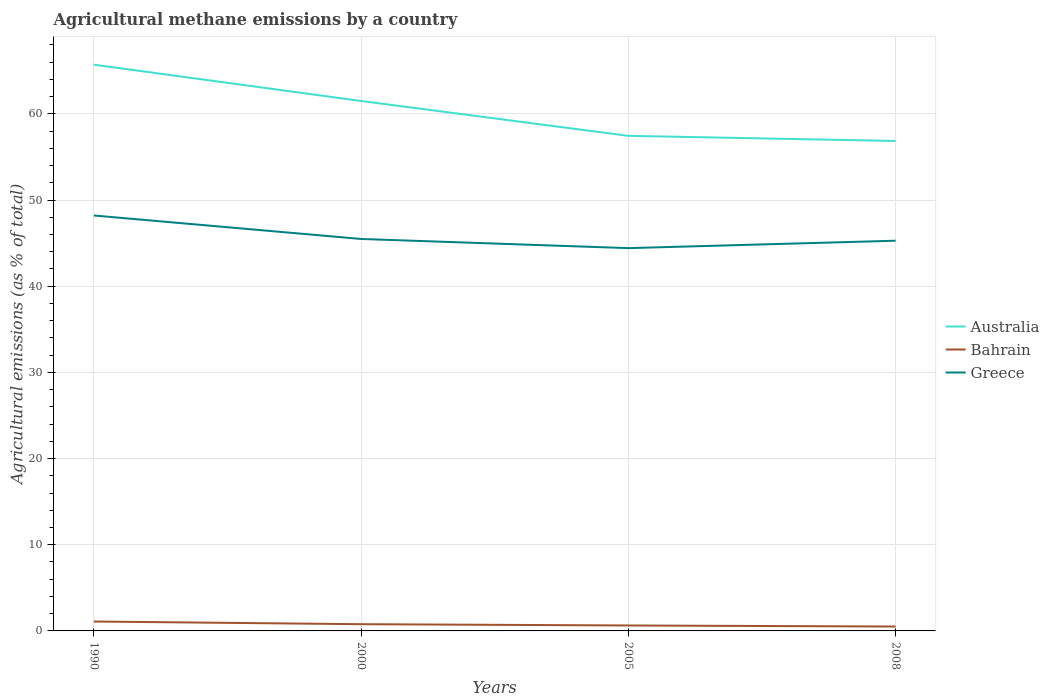How many different coloured lines are there?
Ensure brevity in your answer.  3. Does the line corresponding to Greece intersect with the line corresponding to Australia?
Your answer should be very brief. No. Across all years, what is the maximum amount of agricultural methane emitted in Bahrain?
Your response must be concise. 0.51. In which year was the amount of agricultural methane emitted in Australia maximum?
Ensure brevity in your answer.  2008. What is the total amount of agricultural methane emitted in Australia in the graph?
Give a very brief answer. 8.26. What is the difference between the highest and the second highest amount of agricultural methane emitted in Australia?
Provide a succinct answer. 8.85. What is the difference between the highest and the lowest amount of agricultural methane emitted in Australia?
Your answer should be compact. 2. Is the amount of agricultural methane emitted in Australia strictly greater than the amount of agricultural methane emitted in Greece over the years?
Provide a short and direct response. No. How many lines are there?
Offer a very short reply. 3. Does the graph contain any zero values?
Provide a short and direct response. No. How are the legend labels stacked?
Give a very brief answer. Vertical. What is the title of the graph?
Keep it short and to the point. Agricultural methane emissions by a country. Does "Least developed countries" appear as one of the legend labels in the graph?
Make the answer very short. No. What is the label or title of the Y-axis?
Your answer should be compact. Agricultural emissions (as % of total). What is the Agricultural emissions (as % of total) of Australia in 1990?
Give a very brief answer. 65.71. What is the Agricultural emissions (as % of total) in Bahrain in 1990?
Make the answer very short. 1.09. What is the Agricultural emissions (as % of total) in Greece in 1990?
Ensure brevity in your answer.  48.21. What is the Agricultural emissions (as % of total) in Australia in 2000?
Your answer should be compact. 61.5. What is the Agricultural emissions (as % of total) in Bahrain in 2000?
Your answer should be very brief. 0.78. What is the Agricultural emissions (as % of total) of Greece in 2000?
Offer a very short reply. 45.48. What is the Agricultural emissions (as % of total) in Australia in 2005?
Offer a terse response. 57.45. What is the Agricultural emissions (as % of total) of Bahrain in 2005?
Offer a terse response. 0.63. What is the Agricultural emissions (as % of total) of Greece in 2005?
Provide a succinct answer. 44.42. What is the Agricultural emissions (as % of total) of Australia in 2008?
Your answer should be compact. 56.85. What is the Agricultural emissions (as % of total) of Bahrain in 2008?
Provide a succinct answer. 0.51. What is the Agricultural emissions (as % of total) in Greece in 2008?
Offer a very short reply. 45.28. Across all years, what is the maximum Agricultural emissions (as % of total) of Australia?
Make the answer very short. 65.71. Across all years, what is the maximum Agricultural emissions (as % of total) in Bahrain?
Give a very brief answer. 1.09. Across all years, what is the maximum Agricultural emissions (as % of total) of Greece?
Your answer should be compact. 48.21. Across all years, what is the minimum Agricultural emissions (as % of total) of Australia?
Your answer should be very brief. 56.85. Across all years, what is the minimum Agricultural emissions (as % of total) of Bahrain?
Your answer should be very brief. 0.51. Across all years, what is the minimum Agricultural emissions (as % of total) in Greece?
Offer a terse response. 44.42. What is the total Agricultural emissions (as % of total) in Australia in the graph?
Ensure brevity in your answer.  241.51. What is the total Agricultural emissions (as % of total) of Bahrain in the graph?
Offer a very short reply. 3.02. What is the total Agricultural emissions (as % of total) of Greece in the graph?
Ensure brevity in your answer.  183.39. What is the difference between the Agricultural emissions (as % of total) in Australia in 1990 and that in 2000?
Offer a very short reply. 4.21. What is the difference between the Agricultural emissions (as % of total) in Bahrain in 1990 and that in 2000?
Offer a terse response. 0.31. What is the difference between the Agricultural emissions (as % of total) in Greece in 1990 and that in 2000?
Provide a succinct answer. 2.72. What is the difference between the Agricultural emissions (as % of total) of Australia in 1990 and that in 2005?
Ensure brevity in your answer.  8.26. What is the difference between the Agricultural emissions (as % of total) in Bahrain in 1990 and that in 2005?
Provide a succinct answer. 0.46. What is the difference between the Agricultural emissions (as % of total) in Greece in 1990 and that in 2005?
Offer a terse response. 3.79. What is the difference between the Agricultural emissions (as % of total) of Australia in 1990 and that in 2008?
Your answer should be very brief. 8.85. What is the difference between the Agricultural emissions (as % of total) in Bahrain in 1990 and that in 2008?
Make the answer very short. 0.58. What is the difference between the Agricultural emissions (as % of total) in Greece in 1990 and that in 2008?
Your response must be concise. 2.93. What is the difference between the Agricultural emissions (as % of total) of Australia in 2000 and that in 2005?
Ensure brevity in your answer.  4.04. What is the difference between the Agricultural emissions (as % of total) of Bahrain in 2000 and that in 2005?
Ensure brevity in your answer.  0.15. What is the difference between the Agricultural emissions (as % of total) in Greece in 2000 and that in 2005?
Offer a terse response. 1.06. What is the difference between the Agricultural emissions (as % of total) of Australia in 2000 and that in 2008?
Your response must be concise. 4.64. What is the difference between the Agricultural emissions (as % of total) of Bahrain in 2000 and that in 2008?
Your answer should be compact. 0.27. What is the difference between the Agricultural emissions (as % of total) of Greece in 2000 and that in 2008?
Provide a succinct answer. 0.2. What is the difference between the Agricultural emissions (as % of total) in Australia in 2005 and that in 2008?
Provide a succinct answer. 0.6. What is the difference between the Agricultural emissions (as % of total) of Bahrain in 2005 and that in 2008?
Your answer should be very brief. 0.12. What is the difference between the Agricultural emissions (as % of total) in Greece in 2005 and that in 2008?
Your response must be concise. -0.86. What is the difference between the Agricultural emissions (as % of total) of Australia in 1990 and the Agricultural emissions (as % of total) of Bahrain in 2000?
Offer a very short reply. 64.93. What is the difference between the Agricultural emissions (as % of total) in Australia in 1990 and the Agricultural emissions (as % of total) in Greece in 2000?
Provide a short and direct response. 20.23. What is the difference between the Agricultural emissions (as % of total) of Bahrain in 1990 and the Agricultural emissions (as % of total) of Greece in 2000?
Your answer should be compact. -44.39. What is the difference between the Agricultural emissions (as % of total) of Australia in 1990 and the Agricultural emissions (as % of total) of Bahrain in 2005?
Provide a short and direct response. 65.08. What is the difference between the Agricultural emissions (as % of total) of Australia in 1990 and the Agricultural emissions (as % of total) of Greece in 2005?
Offer a terse response. 21.29. What is the difference between the Agricultural emissions (as % of total) of Bahrain in 1990 and the Agricultural emissions (as % of total) of Greece in 2005?
Offer a very short reply. -43.33. What is the difference between the Agricultural emissions (as % of total) of Australia in 1990 and the Agricultural emissions (as % of total) of Bahrain in 2008?
Make the answer very short. 65.2. What is the difference between the Agricultural emissions (as % of total) in Australia in 1990 and the Agricultural emissions (as % of total) in Greece in 2008?
Make the answer very short. 20.43. What is the difference between the Agricultural emissions (as % of total) of Bahrain in 1990 and the Agricultural emissions (as % of total) of Greece in 2008?
Give a very brief answer. -44.19. What is the difference between the Agricultural emissions (as % of total) in Australia in 2000 and the Agricultural emissions (as % of total) in Bahrain in 2005?
Ensure brevity in your answer.  60.86. What is the difference between the Agricultural emissions (as % of total) in Australia in 2000 and the Agricultural emissions (as % of total) in Greece in 2005?
Provide a succinct answer. 17.08. What is the difference between the Agricultural emissions (as % of total) of Bahrain in 2000 and the Agricultural emissions (as % of total) of Greece in 2005?
Offer a terse response. -43.64. What is the difference between the Agricultural emissions (as % of total) in Australia in 2000 and the Agricultural emissions (as % of total) in Bahrain in 2008?
Make the answer very short. 60.99. What is the difference between the Agricultural emissions (as % of total) in Australia in 2000 and the Agricultural emissions (as % of total) in Greece in 2008?
Ensure brevity in your answer.  16.22. What is the difference between the Agricultural emissions (as % of total) in Bahrain in 2000 and the Agricultural emissions (as % of total) in Greece in 2008?
Ensure brevity in your answer.  -44.5. What is the difference between the Agricultural emissions (as % of total) in Australia in 2005 and the Agricultural emissions (as % of total) in Bahrain in 2008?
Offer a very short reply. 56.94. What is the difference between the Agricultural emissions (as % of total) in Australia in 2005 and the Agricultural emissions (as % of total) in Greece in 2008?
Offer a very short reply. 12.17. What is the difference between the Agricultural emissions (as % of total) in Bahrain in 2005 and the Agricultural emissions (as % of total) in Greece in 2008?
Offer a terse response. -44.65. What is the average Agricultural emissions (as % of total) of Australia per year?
Provide a short and direct response. 60.38. What is the average Agricultural emissions (as % of total) of Bahrain per year?
Offer a very short reply. 0.75. What is the average Agricultural emissions (as % of total) of Greece per year?
Your answer should be compact. 45.85. In the year 1990, what is the difference between the Agricultural emissions (as % of total) of Australia and Agricultural emissions (as % of total) of Bahrain?
Provide a short and direct response. 64.62. In the year 1990, what is the difference between the Agricultural emissions (as % of total) in Australia and Agricultural emissions (as % of total) in Greece?
Offer a very short reply. 17.5. In the year 1990, what is the difference between the Agricultural emissions (as % of total) in Bahrain and Agricultural emissions (as % of total) in Greece?
Offer a terse response. -47.12. In the year 2000, what is the difference between the Agricultural emissions (as % of total) of Australia and Agricultural emissions (as % of total) of Bahrain?
Offer a terse response. 60.72. In the year 2000, what is the difference between the Agricultural emissions (as % of total) in Australia and Agricultural emissions (as % of total) in Greece?
Offer a very short reply. 16.01. In the year 2000, what is the difference between the Agricultural emissions (as % of total) of Bahrain and Agricultural emissions (as % of total) of Greece?
Ensure brevity in your answer.  -44.7. In the year 2005, what is the difference between the Agricultural emissions (as % of total) of Australia and Agricultural emissions (as % of total) of Bahrain?
Offer a terse response. 56.82. In the year 2005, what is the difference between the Agricultural emissions (as % of total) in Australia and Agricultural emissions (as % of total) in Greece?
Your answer should be very brief. 13.03. In the year 2005, what is the difference between the Agricultural emissions (as % of total) in Bahrain and Agricultural emissions (as % of total) in Greece?
Provide a short and direct response. -43.79. In the year 2008, what is the difference between the Agricultural emissions (as % of total) of Australia and Agricultural emissions (as % of total) of Bahrain?
Your response must be concise. 56.34. In the year 2008, what is the difference between the Agricultural emissions (as % of total) of Australia and Agricultural emissions (as % of total) of Greece?
Offer a very short reply. 11.58. In the year 2008, what is the difference between the Agricultural emissions (as % of total) in Bahrain and Agricultural emissions (as % of total) in Greece?
Provide a succinct answer. -44.77. What is the ratio of the Agricultural emissions (as % of total) in Australia in 1990 to that in 2000?
Your response must be concise. 1.07. What is the ratio of the Agricultural emissions (as % of total) of Bahrain in 1990 to that in 2000?
Provide a short and direct response. 1.4. What is the ratio of the Agricultural emissions (as % of total) in Greece in 1990 to that in 2000?
Offer a terse response. 1.06. What is the ratio of the Agricultural emissions (as % of total) in Australia in 1990 to that in 2005?
Your response must be concise. 1.14. What is the ratio of the Agricultural emissions (as % of total) of Bahrain in 1990 to that in 2005?
Provide a short and direct response. 1.72. What is the ratio of the Agricultural emissions (as % of total) in Greece in 1990 to that in 2005?
Your answer should be very brief. 1.09. What is the ratio of the Agricultural emissions (as % of total) of Australia in 1990 to that in 2008?
Your response must be concise. 1.16. What is the ratio of the Agricultural emissions (as % of total) in Bahrain in 1990 to that in 2008?
Provide a short and direct response. 2.14. What is the ratio of the Agricultural emissions (as % of total) of Greece in 1990 to that in 2008?
Offer a very short reply. 1.06. What is the ratio of the Agricultural emissions (as % of total) of Australia in 2000 to that in 2005?
Provide a short and direct response. 1.07. What is the ratio of the Agricultural emissions (as % of total) in Bahrain in 2000 to that in 2005?
Provide a short and direct response. 1.23. What is the ratio of the Agricultural emissions (as % of total) in Greece in 2000 to that in 2005?
Your answer should be compact. 1.02. What is the ratio of the Agricultural emissions (as % of total) in Australia in 2000 to that in 2008?
Your answer should be very brief. 1.08. What is the ratio of the Agricultural emissions (as % of total) of Bahrain in 2000 to that in 2008?
Provide a short and direct response. 1.53. What is the ratio of the Agricultural emissions (as % of total) of Australia in 2005 to that in 2008?
Provide a short and direct response. 1.01. What is the ratio of the Agricultural emissions (as % of total) of Bahrain in 2005 to that in 2008?
Give a very brief answer. 1.24. What is the ratio of the Agricultural emissions (as % of total) of Greece in 2005 to that in 2008?
Provide a succinct answer. 0.98. What is the difference between the highest and the second highest Agricultural emissions (as % of total) in Australia?
Give a very brief answer. 4.21. What is the difference between the highest and the second highest Agricultural emissions (as % of total) of Bahrain?
Your answer should be very brief. 0.31. What is the difference between the highest and the second highest Agricultural emissions (as % of total) in Greece?
Give a very brief answer. 2.72. What is the difference between the highest and the lowest Agricultural emissions (as % of total) in Australia?
Your answer should be very brief. 8.85. What is the difference between the highest and the lowest Agricultural emissions (as % of total) of Bahrain?
Keep it short and to the point. 0.58. What is the difference between the highest and the lowest Agricultural emissions (as % of total) in Greece?
Give a very brief answer. 3.79. 